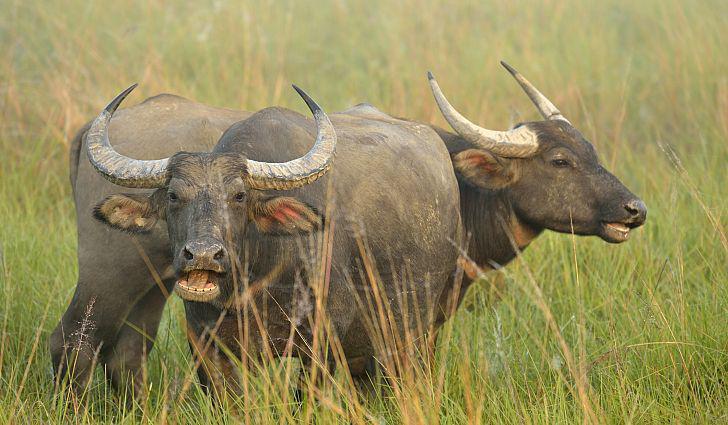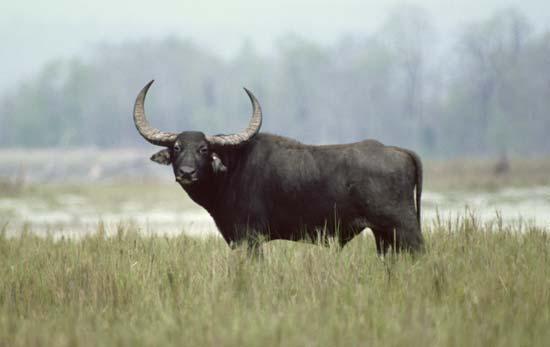The first image is the image on the left, the second image is the image on the right. Analyze the images presented: Is the assertion "The image on the left contains only one water buffalo." valid? Answer yes or no. No. The first image is the image on the left, the second image is the image on the right. Analyze the images presented: Is the assertion "One image contains exactly two adult oxen." valid? Answer yes or no. Yes. 